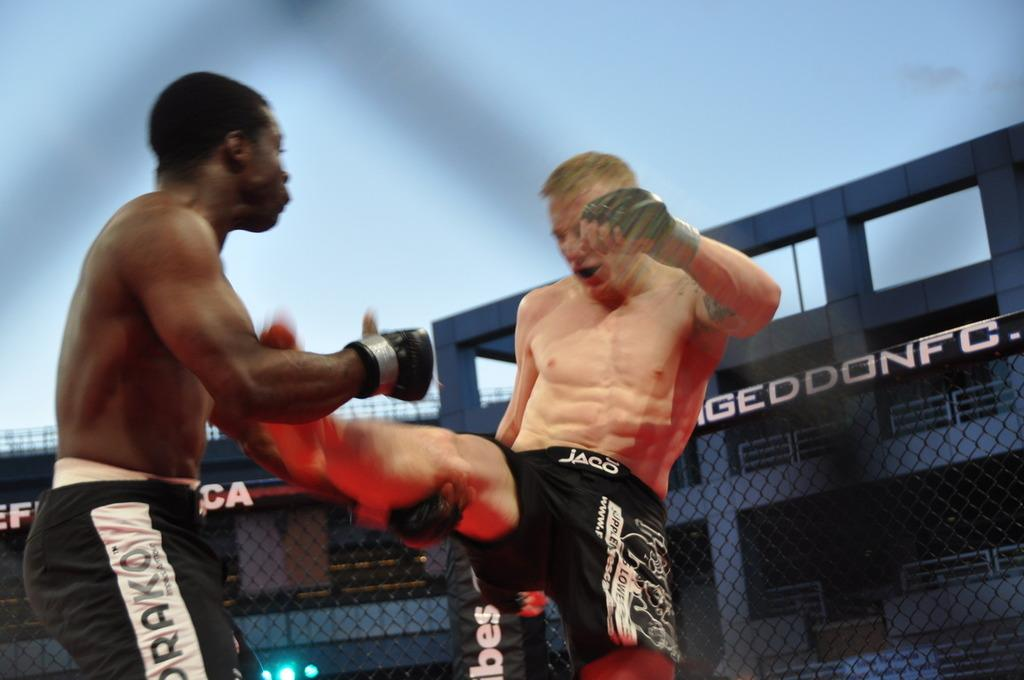<image>
Give a short and clear explanation of the subsequent image. A fighter wearing Jaco shorts kicks at his opponent. 